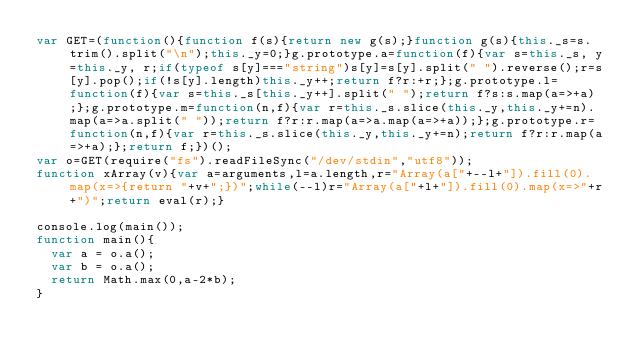Convert code to text. <code><loc_0><loc_0><loc_500><loc_500><_JavaScript_>var GET=(function(){function f(s){return new g(s);}function g(s){this._s=s.trim().split("\n");this._y=0;}g.prototype.a=function(f){var s=this._s, y=this._y, r;if(typeof s[y]==="string")s[y]=s[y].split(" ").reverse();r=s[y].pop();if(!s[y].length)this._y++;return f?r:+r;};g.prototype.l=function(f){var s=this._s[this._y++].split(" ");return f?s:s.map(a=>+a);};g.prototype.m=function(n,f){var r=this._s.slice(this._y,this._y+=n).map(a=>a.split(" "));return f?r:r.map(a=>a.map(a=>+a));};g.prototype.r=function(n,f){var r=this._s.slice(this._y,this._y+=n);return f?r:r.map(a=>+a);};return f;})();
var o=GET(require("fs").readFileSync("/dev/stdin","utf8"));
function xArray(v){var a=arguments,l=a.length,r="Array(a["+--l+"]).fill(0).map(x=>{return "+v+";})";while(--l)r="Array(a["+l+"]).fill(0).map(x=>"+r+")";return eval(r);}

console.log(main());
function main(){
  var a = o.a();
  var b = o.a();
  return Math.max(0,a-2*b);
}</code> 